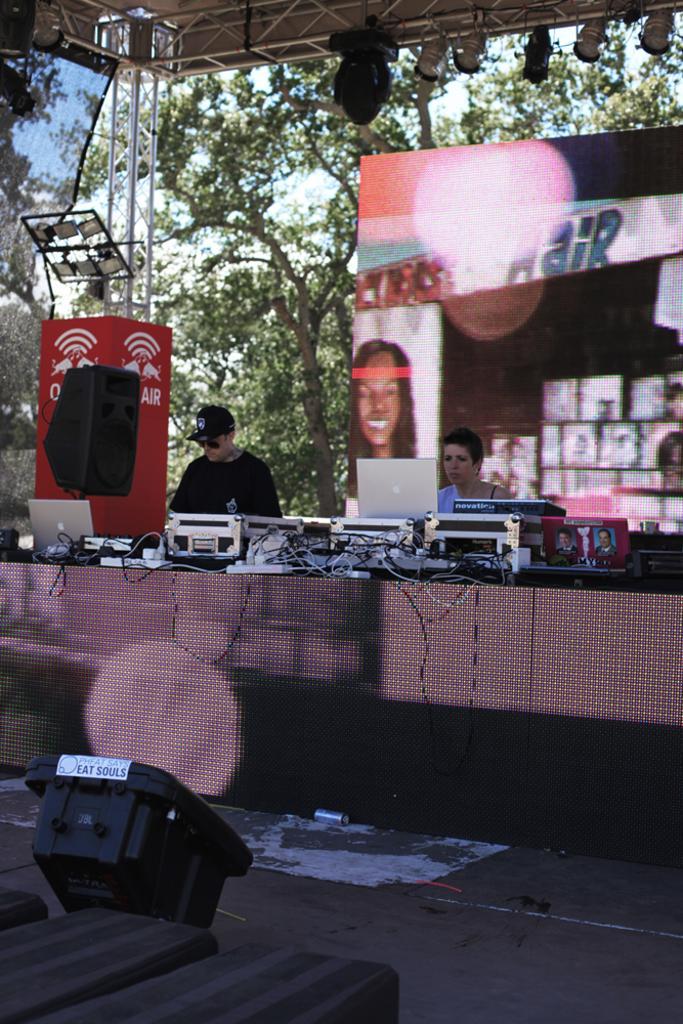How would you summarize this image in a sentence or two? In this picture I can see focus lights, lighting truss, there are two persons, there is a speaker, there is a screen, and there are laptops, rack cases, cables, a photo frame and some other items on the table, there is a board , there are trees, and in the background there is sky. 